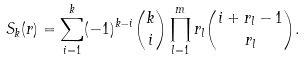<formula> <loc_0><loc_0><loc_500><loc_500>S _ { k } ( { r } ) = \sum _ { i = 1 } ^ { k } ( - 1 ) ^ { k - i } \binom { k } { i } \prod _ { l = 1 } ^ { m } r _ { l } \binom { i + r _ { l } - 1 } { r _ { l } } .</formula> 